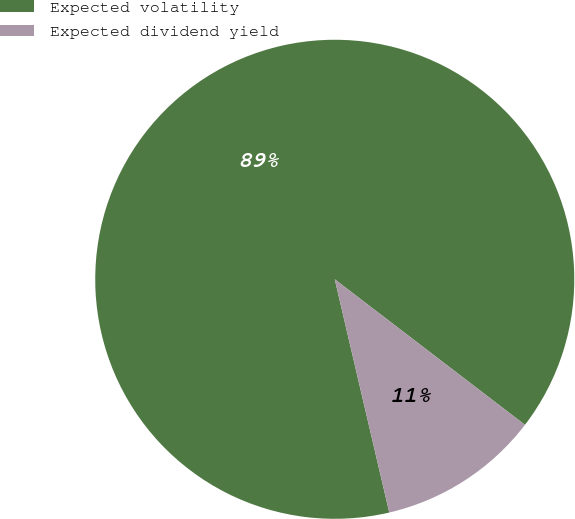Convert chart to OTSL. <chart><loc_0><loc_0><loc_500><loc_500><pie_chart><fcel>Expected volatility<fcel>Expected dividend yield<nl><fcel>89.05%<fcel>10.95%<nl></chart> 